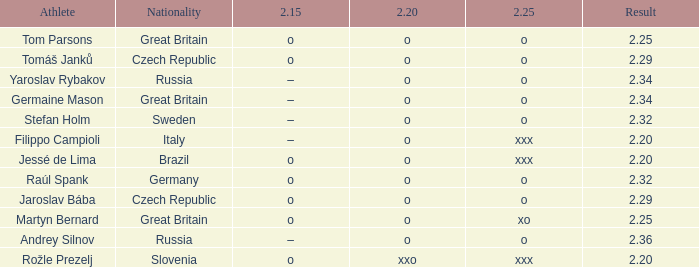What is the 2.15 for Tom Parsons? O. 